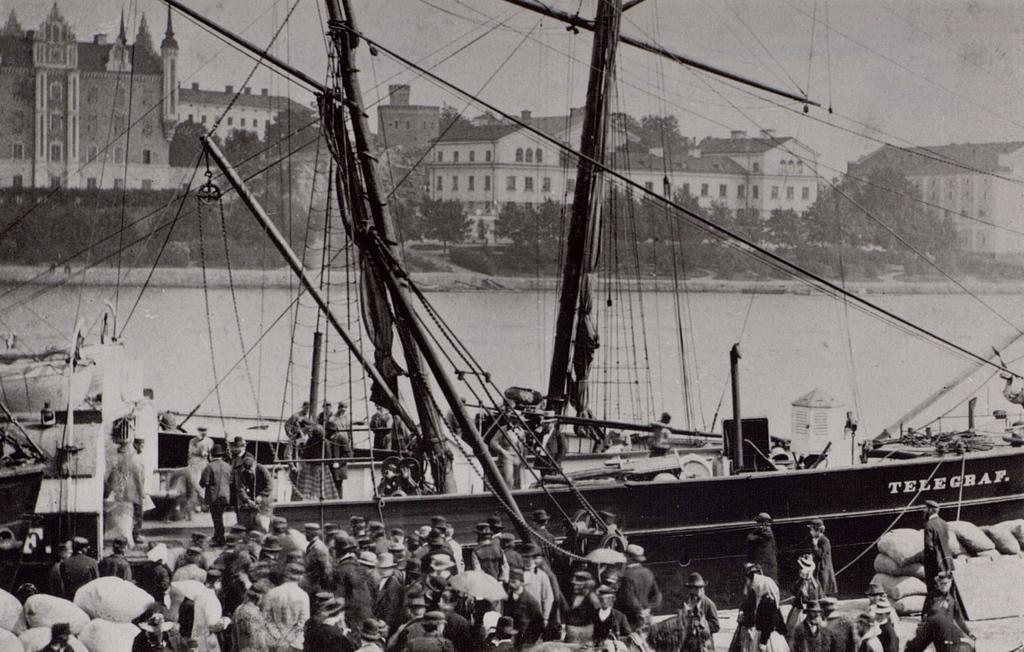Please provide a concise description of this image. In this picture I can observe some people in the bottom of the picture. In the middle of the picture I can observe ship floating on the water. In the background there are buildings and sky. 